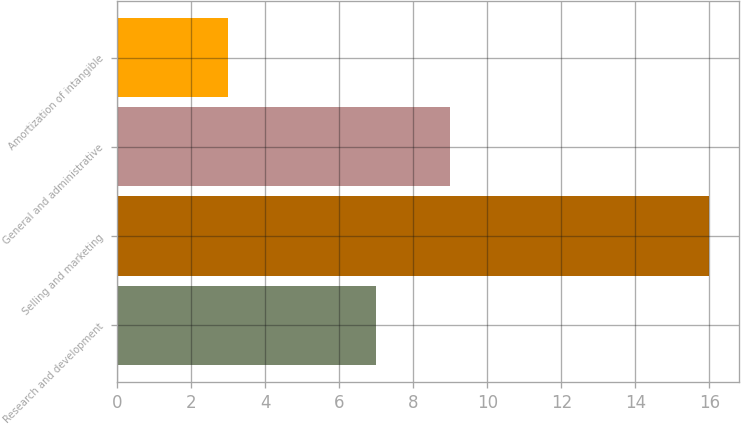Convert chart. <chart><loc_0><loc_0><loc_500><loc_500><bar_chart><fcel>Research and development<fcel>Selling and marketing<fcel>General and administrative<fcel>Amortization of intangible<nl><fcel>7<fcel>16<fcel>9<fcel>3<nl></chart> 